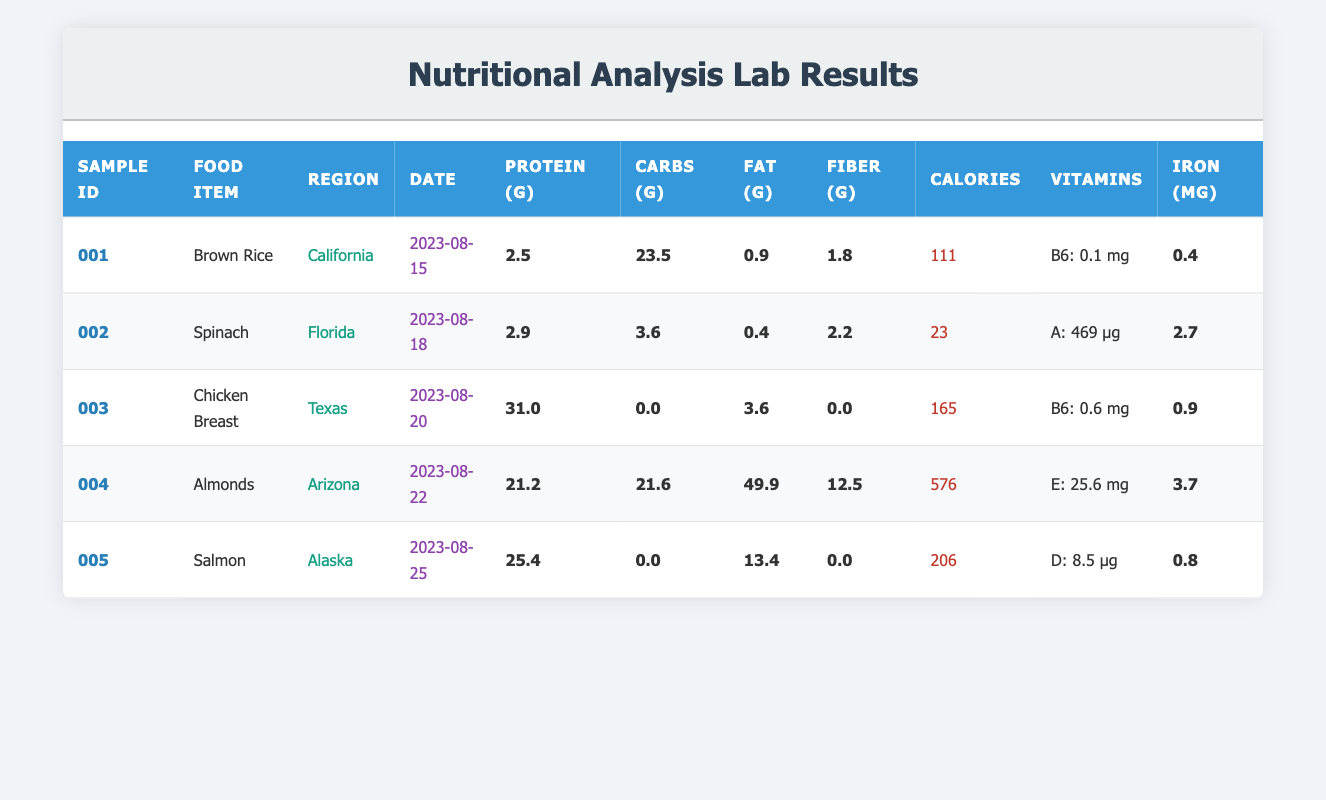What is the protein content of Almonds? According to the table, the protein content for Almonds is mentioned directly under the respective column. By locating Almonds in the food item row, we can see its protein content listed as 21.2 grams.
Answer: 21.2 Which food item has the highest fat content? To determine the food item with the highest fat content, we compare the fat values from the table: Brown Rice (0.9g), Spinach (0.4g), Chicken Breast (3.6g), Almonds (49.9g), and Salmon (13.4g). Almonds has the maximum value of 49.9 grams.
Answer: Almonds What is the total carbohydrate content of the food items sampled? To calculate the total carbohydrate content, we add the carbohydrate values from all food items: Brown Rice (23.5g) + Spinach (3.6g) + Chicken Breast (0.0g) + Almonds (21.6g) + Salmon (0.0g) = 48.7 grams.
Answer: 48.7 Does the Chicken Breast have any fiber content? Looking at the table, the fiber content for Chicken Breast is recorded as 0.0 grams, indicating that there is no fiber present in this food sample.
Answer: No What is the average iron content of food samples? To find the average iron content, we sum up all the iron values: Brown Rice (0.4mg) + Spinach (2.7mg) + Chicken Breast (0.9mg) + Almonds (3.7mg) + Salmon (0.8mg) = 8.5mg. There are 5 samples, thus the average is 8.5mg / 5 = 1.7mg.
Answer: 1.7 Which region collected food items with the highest calories, and what is the value? We must compare the calorie values: Brown Rice (111), Spinach (23), Chicken Breast (165), Almonds (576), and Salmon (206). The highest calorie value is 576 from Almonds, collected in Arizona.
Answer: Arizona, 576 Is there any food item with zero carbohydrates? Reviewing the carbohydrate content in the table shows both Chicken Breast and Salmon have 0.0 grams of carbohydrates. Thus, we confirm that food items exist with this value.
Answer: Yes Identify the food item with the highest vitamin A content and its value. The only food item that lists vitamin A content is Spinach, which has 469 micrograms. The other food items do not list vitamin A content. Therefore, Spinach has the highest value for this nutrient.
Answer: Spinach, 469 